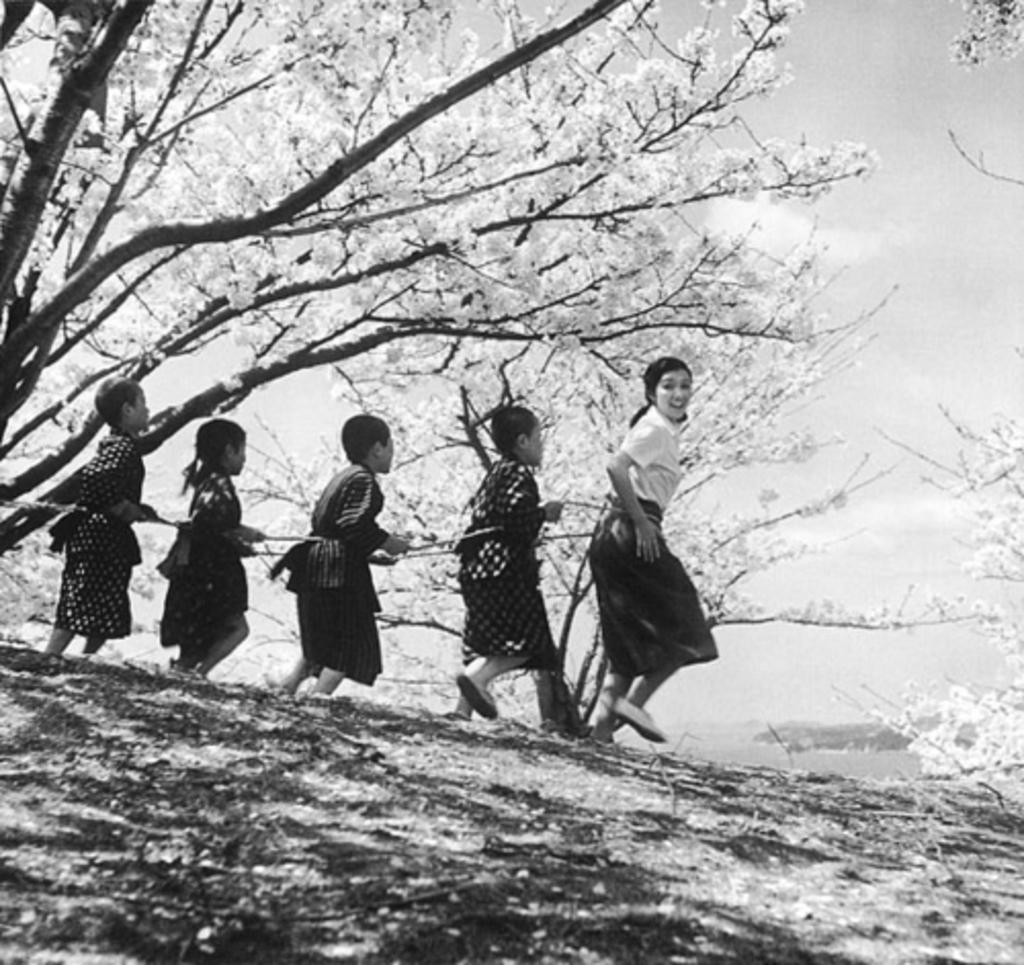What is the color scheme of the image? The image is black and white. What can be seen in the image besides the color scheme? There are people and trees in the image. What is visible in the background of the image? The sky is visible in the image. What are the people holding in the image? The people are holding a rope. What type of fruit can be seen hanging from the trees in the image? There is no fruit visible in the image; it is a black and white image, and the trees are not detailed enough to determine the presence of fruit. What type of brass instrument is being played by the people in the image? There is no brass instrument present in the image; the people are holding a rope, not a musical instrument. 